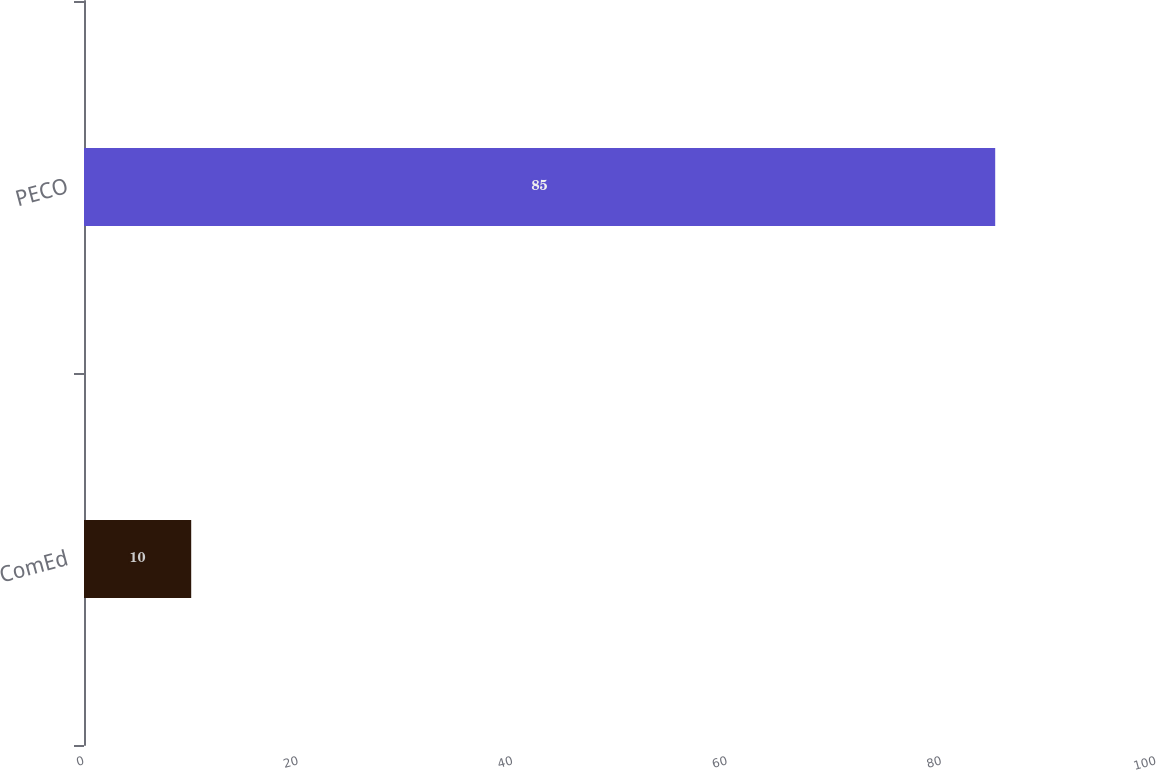Convert chart to OTSL. <chart><loc_0><loc_0><loc_500><loc_500><bar_chart><fcel>ComEd<fcel>PECO<nl><fcel>10<fcel>85<nl></chart> 